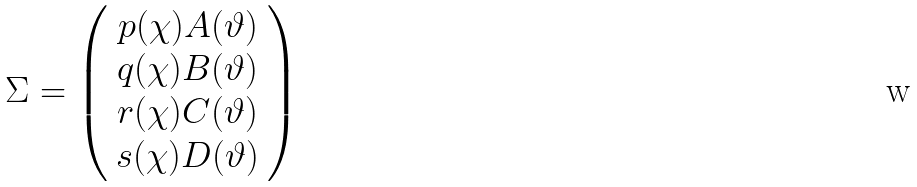Convert formula to latex. <formula><loc_0><loc_0><loc_500><loc_500>\Sigma = \left ( \begin{array} { c } p ( \chi ) A ( \vartheta ) \\ q ( \chi ) B ( \vartheta ) \\ r ( \chi ) C ( \vartheta ) \\ s ( \chi ) D ( \vartheta ) \end{array} \right )</formula> 